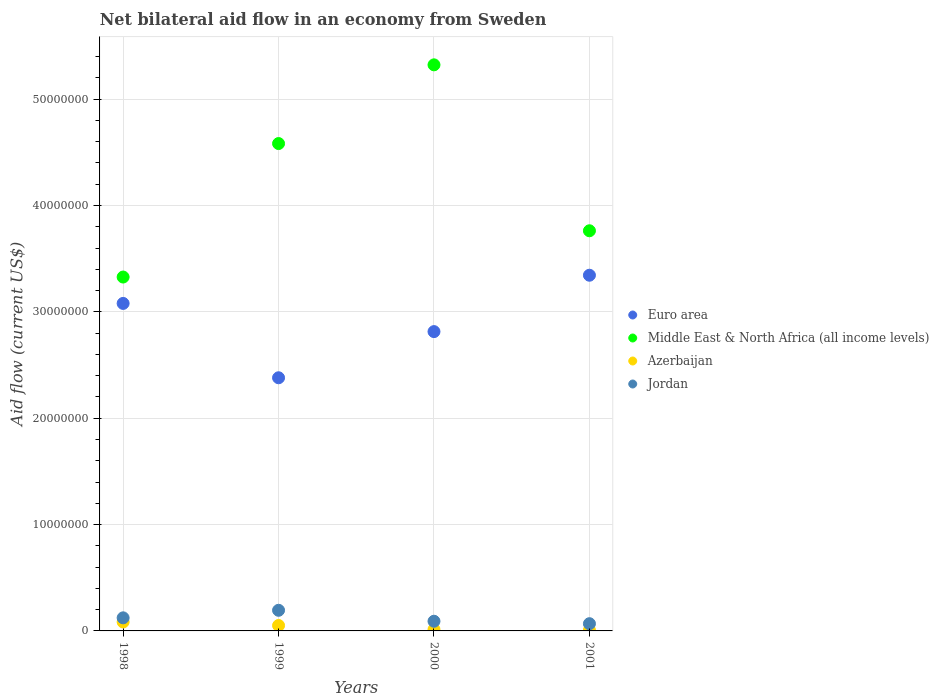How many different coloured dotlines are there?
Your answer should be very brief. 4. Is the number of dotlines equal to the number of legend labels?
Make the answer very short. Yes. What is the net bilateral aid flow in Middle East & North Africa (all income levels) in 1999?
Give a very brief answer. 4.58e+07. Across all years, what is the maximum net bilateral aid flow in Azerbaijan?
Your answer should be compact. 8.40e+05. Across all years, what is the minimum net bilateral aid flow in Middle East & North Africa (all income levels)?
Your answer should be compact. 3.33e+07. What is the total net bilateral aid flow in Jordan in the graph?
Your answer should be very brief. 4.76e+06. What is the difference between the net bilateral aid flow in Euro area in 1998 and that in 2001?
Offer a very short reply. -2.65e+06. What is the difference between the net bilateral aid flow in Jordan in 1999 and the net bilateral aid flow in Middle East & North Africa (all income levels) in 2001?
Make the answer very short. -3.57e+07. What is the average net bilateral aid flow in Middle East & North Africa (all income levels) per year?
Your response must be concise. 4.25e+07. What is the ratio of the net bilateral aid flow in Azerbaijan in 2000 to that in 2001?
Offer a very short reply. 1.86. Is the difference between the net bilateral aid flow in Jordan in 1998 and 2001 greater than the difference between the net bilateral aid flow in Azerbaijan in 1998 and 2001?
Provide a short and direct response. No. What is the difference between the highest and the second highest net bilateral aid flow in Middle East & North Africa (all income levels)?
Give a very brief answer. 7.40e+06. What is the difference between the highest and the lowest net bilateral aid flow in Middle East & North Africa (all income levels)?
Your answer should be very brief. 2.00e+07. Is the sum of the net bilateral aid flow in Middle East & North Africa (all income levels) in 2000 and 2001 greater than the maximum net bilateral aid flow in Euro area across all years?
Offer a terse response. Yes. Does the net bilateral aid flow in Middle East & North Africa (all income levels) monotonically increase over the years?
Provide a succinct answer. No. How many dotlines are there?
Offer a very short reply. 4. How many years are there in the graph?
Your answer should be very brief. 4. What is the difference between two consecutive major ticks on the Y-axis?
Your answer should be very brief. 1.00e+07. Does the graph contain grids?
Your response must be concise. Yes. Where does the legend appear in the graph?
Offer a very short reply. Center right. What is the title of the graph?
Your answer should be very brief. Net bilateral aid flow in an economy from Sweden. Does "Estonia" appear as one of the legend labels in the graph?
Offer a terse response. No. What is the label or title of the X-axis?
Your answer should be compact. Years. What is the label or title of the Y-axis?
Your response must be concise. Aid flow (current US$). What is the Aid flow (current US$) of Euro area in 1998?
Ensure brevity in your answer.  3.08e+07. What is the Aid flow (current US$) of Middle East & North Africa (all income levels) in 1998?
Your response must be concise. 3.33e+07. What is the Aid flow (current US$) of Azerbaijan in 1998?
Your answer should be very brief. 8.40e+05. What is the Aid flow (current US$) in Jordan in 1998?
Keep it short and to the point. 1.23e+06. What is the Aid flow (current US$) in Euro area in 1999?
Make the answer very short. 2.38e+07. What is the Aid flow (current US$) in Middle East & North Africa (all income levels) in 1999?
Give a very brief answer. 4.58e+07. What is the Aid flow (current US$) in Azerbaijan in 1999?
Ensure brevity in your answer.  5.10e+05. What is the Aid flow (current US$) in Jordan in 1999?
Your answer should be very brief. 1.94e+06. What is the Aid flow (current US$) of Euro area in 2000?
Offer a very short reply. 2.81e+07. What is the Aid flow (current US$) in Middle East & North Africa (all income levels) in 2000?
Offer a terse response. 5.32e+07. What is the Aid flow (current US$) of Azerbaijan in 2000?
Make the answer very short. 1.30e+05. What is the Aid flow (current US$) of Jordan in 2000?
Make the answer very short. 9.10e+05. What is the Aid flow (current US$) in Euro area in 2001?
Your response must be concise. 3.34e+07. What is the Aid flow (current US$) in Middle East & North Africa (all income levels) in 2001?
Make the answer very short. 3.76e+07. What is the Aid flow (current US$) in Azerbaijan in 2001?
Your answer should be very brief. 7.00e+04. What is the Aid flow (current US$) in Jordan in 2001?
Keep it short and to the point. 6.80e+05. Across all years, what is the maximum Aid flow (current US$) of Euro area?
Provide a succinct answer. 3.34e+07. Across all years, what is the maximum Aid flow (current US$) in Middle East & North Africa (all income levels)?
Make the answer very short. 5.32e+07. Across all years, what is the maximum Aid flow (current US$) of Azerbaijan?
Ensure brevity in your answer.  8.40e+05. Across all years, what is the maximum Aid flow (current US$) in Jordan?
Offer a very short reply. 1.94e+06. Across all years, what is the minimum Aid flow (current US$) in Euro area?
Your answer should be very brief. 2.38e+07. Across all years, what is the minimum Aid flow (current US$) in Middle East & North Africa (all income levels)?
Keep it short and to the point. 3.33e+07. Across all years, what is the minimum Aid flow (current US$) of Jordan?
Make the answer very short. 6.80e+05. What is the total Aid flow (current US$) of Euro area in the graph?
Make the answer very short. 1.16e+08. What is the total Aid flow (current US$) of Middle East & North Africa (all income levels) in the graph?
Your response must be concise. 1.70e+08. What is the total Aid flow (current US$) of Azerbaijan in the graph?
Provide a succinct answer. 1.55e+06. What is the total Aid flow (current US$) in Jordan in the graph?
Keep it short and to the point. 4.76e+06. What is the difference between the Aid flow (current US$) of Euro area in 1998 and that in 1999?
Provide a short and direct response. 6.99e+06. What is the difference between the Aid flow (current US$) of Middle East & North Africa (all income levels) in 1998 and that in 1999?
Provide a short and direct response. -1.26e+07. What is the difference between the Aid flow (current US$) of Jordan in 1998 and that in 1999?
Provide a short and direct response. -7.10e+05. What is the difference between the Aid flow (current US$) in Euro area in 1998 and that in 2000?
Make the answer very short. 2.65e+06. What is the difference between the Aid flow (current US$) of Middle East & North Africa (all income levels) in 1998 and that in 2000?
Give a very brief answer. -2.00e+07. What is the difference between the Aid flow (current US$) of Azerbaijan in 1998 and that in 2000?
Make the answer very short. 7.10e+05. What is the difference between the Aid flow (current US$) in Jordan in 1998 and that in 2000?
Make the answer very short. 3.20e+05. What is the difference between the Aid flow (current US$) in Euro area in 1998 and that in 2001?
Provide a short and direct response. -2.65e+06. What is the difference between the Aid flow (current US$) of Middle East & North Africa (all income levels) in 1998 and that in 2001?
Provide a short and direct response. -4.35e+06. What is the difference between the Aid flow (current US$) in Azerbaijan in 1998 and that in 2001?
Provide a succinct answer. 7.70e+05. What is the difference between the Aid flow (current US$) in Euro area in 1999 and that in 2000?
Keep it short and to the point. -4.34e+06. What is the difference between the Aid flow (current US$) of Middle East & North Africa (all income levels) in 1999 and that in 2000?
Give a very brief answer. -7.40e+06. What is the difference between the Aid flow (current US$) in Jordan in 1999 and that in 2000?
Make the answer very short. 1.03e+06. What is the difference between the Aid flow (current US$) in Euro area in 1999 and that in 2001?
Keep it short and to the point. -9.64e+06. What is the difference between the Aid flow (current US$) of Middle East & North Africa (all income levels) in 1999 and that in 2001?
Ensure brevity in your answer.  8.20e+06. What is the difference between the Aid flow (current US$) in Jordan in 1999 and that in 2001?
Your answer should be very brief. 1.26e+06. What is the difference between the Aid flow (current US$) of Euro area in 2000 and that in 2001?
Ensure brevity in your answer.  -5.30e+06. What is the difference between the Aid flow (current US$) of Middle East & North Africa (all income levels) in 2000 and that in 2001?
Offer a terse response. 1.56e+07. What is the difference between the Aid flow (current US$) in Jordan in 2000 and that in 2001?
Ensure brevity in your answer.  2.30e+05. What is the difference between the Aid flow (current US$) in Euro area in 1998 and the Aid flow (current US$) in Middle East & North Africa (all income levels) in 1999?
Provide a succinct answer. -1.50e+07. What is the difference between the Aid flow (current US$) in Euro area in 1998 and the Aid flow (current US$) in Azerbaijan in 1999?
Ensure brevity in your answer.  3.03e+07. What is the difference between the Aid flow (current US$) in Euro area in 1998 and the Aid flow (current US$) in Jordan in 1999?
Your response must be concise. 2.88e+07. What is the difference between the Aid flow (current US$) of Middle East & North Africa (all income levels) in 1998 and the Aid flow (current US$) of Azerbaijan in 1999?
Make the answer very short. 3.28e+07. What is the difference between the Aid flow (current US$) of Middle East & North Africa (all income levels) in 1998 and the Aid flow (current US$) of Jordan in 1999?
Make the answer very short. 3.13e+07. What is the difference between the Aid flow (current US$) in Azerbaijan in 1998 and the Aid flow (current US$) in Jordan in 1999?
Provide a short and direct response. -1.10e+06. What is the difference between the Aid flow (current US$) of Euro area in 1998 and the Aid flow (current US$) of Middle East & North Africa (all income levels) in 2000?
Give a very brief answer. -2.24e+07. What is the difference between the Aid flow (current US$) of Euro area in 1998 and the Aid flow (current US$) of Azerbaijan in 2000?
Give a very brief answer. 3.07e+07. What is the difference between the Aid flow (current US$) of Euro area in 1998 and the Aid flow (current US$) of Jordan in 2000?
Your response must be concise. 2.99e+07. What is the difference between the Aid flow (current US$) of Middle East & North Africa (all income levels) in 1998 and the Aid flow (current US$) of Azerbaijan in 2000?
Ensure brevity in your answer.  3.31e+07. What is the difference between the Aid flow (current US$) in Middle East & North Africa (all income levels) in 1998 and the Aid flow (current US$) in Jordan in 2000?
Ensure brevity in your answer.  3.24e+07. What is the difference between the Aid flow (current US$) in Euro area in 1998 and the Aid flow (current US$) in Middle East & North Africa (all income levels) in 2001?
Your answer should be compact. -6.83e+06. What is the difference between the Aid flow (current US$) of Euro area in 1998 and the Aid flow (current US$) of Azerbaijan in 2001?
Offer a very short reply. 3.07e+07. What is the difference between the Aid flow (current US$) of Euro area in 1998 and the Aid flow (current US$) of Jordan in 2001?
Your answer should be compact. 3.01e+07. What is the difference between the Aid flow (current US$) of Middle East & North Africa (all income levels) in 1998 and the Aid flow (current US$) of Azerbaijan in 2001?
Your answer should be very brief. 3.32e+07. What is the difference between the Aid flow (current US$) in Middle East & North Africa (all income levels) in 1998 and the Aid flow (current US$) in Jordan in 2001?
Provide a short and direct response. 3.26e+07. What is the difference between the Aid flow (current US$) in Azerbaijan in 1998 and the Aid flow (current US$) in Jordan in 2001?
Your response must be concise. 1.60e+05. What is the difference between the Aid flow (current US$) in Euro area in 1999 and the Aid flow (current US$) in Middle East & North Africa (all income levels) in 2000?
Give a very brief answer. -2.94e+07. What is the difference between the Aid flow (current US$) of Euro area in 1999 and the Aid flow (current US$) of Azerbaijan in 2000?
Provide a succinct answer. 2.37e+07. What is the difference between the Aid flow (current US$) in Euro area in 1999 and the Aid flow (current US$) in Jordan in 2000?
Offer a very short reply. 2.29e+07. What is the difference between the Aid flow (current US$) of Middle East & North Africa (all income levels) in 1999 and the Aid flow (current US$) of Azerbaijan in 2000?
Make the answer very short. 4.57e+07. What is the difference between the Aid flow (current US$) in Middle East & North Africa (all income levels) in 1999 and the Aid flow (current US$) in Jordan in 2000?
Offer a terse response. 4.49e+07. What is the difference between the Aid flow (current US$) of Azerbaijan in 1999 and the Aid flow (current US$) of Jordan in 2000?
Your answer should be compact. -4.00e+05. What is the difference between the Aid flow (current US$) in Euro area in 1999 and the Aid flow (current US$) in Middle East & North Africa (all income levels) in 2001?
Offer a terse response. -1.38e+07. What is the difference between the Aid flow (current US$) of Euro area in 1999 and the Aid flow (current US$) of Azerbaijan in 2001?
Your response must be concise. 2.37e+07. What is the difference between the Aid flow (current US$) of Euro area in 1999 and the Aid flow (current US$) of Jordan in 2001?
Your answer should be very brief. 2.31e+07. What is the difference between the Aid flow (current US$) in Middle East & North Africa (all income levels) in 1999 and the Aid flow (current US$) in Azerbaijan in 2001?
Make the answer very short. 4.58e+07. What is the difference between the Aid flow (current US$) of Middle East & North Africa (all income levels) in 1999 and the Aid flow (current US$) of Jordan in 2001?
Provide a succinct answer. 4.51e+07. What is the difference between the Aid flow (current US$) in Azerbaijan in 1999 and the Aid flow (current US$) in Jordan in 2001?
Your answer should be compact. -1.70e+05. What is the difference between the Aid flow (current US$) in Euro area in 2000 and the Aid flow (current US$) in Middle East & North Africa (all income levels) in 2001?
Provide a succinct answer. -9.48e+06. What is the difference between the Aid flow (current US$) of Euro area in 2000 and the Aid flow (current US$) of Azerbaijan in 2001?
Provide a succinct answer. 2.81e+07. What is the difference between the Aid flow (current US$) of Euro area in 2000 and the Aid flow (current US$) of Jordan in 2001?
Make the answer very short. 2.75e+07. What is the difference between the Aid flow (current US$) of Middle East & North Africa (all income levels) in 2000 and the Aid flow (current US$) of Azerbaijan in 2001?
Ensure brevity in your answer.  5.32e+07. What is the difference between the Aid flow (current US$) in Middle East & North Africa (all income levels) in 2000 and the Aid flow (current US$) in Jordan in 2001?
Offer a terse response. 5.25e+07. What is the difference between the Aid flow (current US$) in Azerbaijan in 2000 and the Aid flow (current US$) in Jordan in 2001?
Offer a very short reply. -5.50e+05. What is the average Aid flow (current US$) in Euro area per year?
Ensure brevity in your answer.  2.90e+07. What is the average Aid flow (current US$) in Middle East & North Africa (all income levels) per year?
Provide a short and direct response. 4.25e+07. What is the average Aid flow (current US$) of Azerbaijan per year?
Provide a short and direct response. 3.88e+05. What is the average Aid flow (current US$) in Jordan per year?
Offer a very short reply. 1.19e+06. In the year 1998, what is the difference between the Aid flow (current US$) of Euro area and Aid flow (current US$) of Middle East & North Africa (all income levels)?
Offer a very short reply. -2.48e+06. In the year 1998, what is the difference between the Aid flow (current US$) of Euro area and Aid flow (current US$) of Azerbaijan?
Provide a short and direct response. 3.00e+07. In the year 1998, what is the difference between the Aid flow (current US$) in Euro area and Aid flow (current US$) in Jordan?
Provide a short and direct response. 2.96e+07. In the year 1998, what is the difference between the Aid flow (current US$) of Middle East & North Africa (all income levels) and Aid flow (current US$) of Azerbaijan?
Ensure brevity in your answer.  3.24e+07. In the year 1998, what is the difference between the Aid flow (current US$) in Middle East & North Africa (all income levels) and Aid flow (current US$) in Jordan?
Provide a short and direct response. 3.20e+07. In the year 1998, what is the difference between the Aid flow (current US$) in Azerbaijan and Aid flow (current US$) in Jordan?
Your response must be concise. -3.90e+05. In the year 1999, what is the difference between the Aid flow (current US$) of Euro area and Aid flow (current US$) of Middle East & North Africa (all income levels)?
Ensure brevity in your answer.  -2.20e+07. In the year 1999, what is the difference between the Aid flow (current US$) of Euro area and Aid flow (current US$) of Azerbaijan?
Keep it short and to the point. 2.33e+07. In the year 1999, what is the difference between the Aid flow (current US$) in Euro area and Aid flow (current US$) in Jordan?
Ensure brevity in your answer.  2.19e+07. In the year 1999, what is the difference between the Aid flow (current US$) in Middle East & North Africa (all income levels) and Aid flow (current US$) in Azerbaijan?
Offer a terse response. 4.53e+07. In the year 1999, what is the difference between the Aid flow (current US$) in Middle East & North Africa (all income levels) and Aid flow (current US$) in Jordan?
Offer a very short reply. 4.39e+07. In the year 1999, what is the difference between the Aid flow (current US$) in Azerbaijan and Aid flow (current US$) in Jordan?
Ensure brevity in your answer.  -1.43e+06. In the year 2000, what is the difference between the Aid flow (current US$) in Euro area and Aid flow (current US$) in Middle East & North Africa (all income levels)?
Give a very brief answer. -2.51e+07. In the year 2000, what is the difference between the Aid flow (current US$) of Euro area and Aid flow (current US$) of Azerbaijan?
Your answer should be compact. 2.80e+07. In the year 2000, what is the difference between the Aid flow (current US$) of Euro area and Aid flow (current US$) of Jordan?
Offer a very short reply. 2.72e+07. In the year 2000, what is the difference between the Aid flow (current US$) in Middle East & North Africa (all income levels) and Aid flow (current US$) in Azerbaijan?
Ensure brevity in your answer.  5.31e+07. In the year 2000, what is the difference between the Aid flow (current US$) of Middle East & North Africa (all income levels) and Aid flow (current US$) of Jordan?
Your answer should be very brief. 5.23e+07. In the year 2000, what is the difference between the Aid flow (current US$) of Azerbaijan and Aid flow (current US$) of Jordan?
Ensure brevity in your answer.  -7.80e+05. In the year 2001, what is the difference between the Aid flow (current US$) in Euro area and Aid flow (current US$) in Middle East & North Africa (all income levels)?
Ensure brevity in your answer.  -4.18e+06. In the year 2001, what is the difference between the Aid flow (current US$) in Euro area and Aid flow (current US$) in Azerbaijan?
Your response must be concise. 3.34e+07. In the year 2001, what is the difference between the Aid flow (current US$) in Euro area and Aid flow (current US$) in Jordan?
Your answer should be very brief. 3.28e+07. In the year 2001, what is the difference between the Aid flow (current US$) in Middle East & North Africa (all income levels) and Aid flow (current US$) in Azerbaijan?
Your response must be concise. 3.76e+07. In the year 2001, what is the difference between the Aid flow (current US$) of Middle East & North Africa (all income levels) and Aid flow (current US$) of Jordan?
Give a very brief answer. 3.69e+07. In the year 2001, what is the difference between the Aid flow (current US$) of Azerbaijan and Aid flow (current US$) of Jordan?
Give a very brief answer. -6.10e+05. What is the ratio of the Aid flow (current US$) in Euro area in 1998 to that in 1999?
Make the answer very short. 1.29. What is the ratio of the Aid flow (current US$) in Middle East & North Africa (all income levels) in 1998 to that in 1999?
Offer a terse response. 0.73. What is the ratio of the Aid flow (current US$) in Azerbaijan in 1998 to that in 1999?
Offer a terse response. 1.65. What is the ratio of the Aid flow (current US$) in Jordan in 1998 to that in 1999?
Your answer should be very brief. 0.63. What is the ratio of the Aid flow (current US$) of Euro area in 1998 to that in 2000?
Give a very brief answer. 1.09. What is the ratio of the Aid flow (current US$) of Middle East & North Africa (all income levels) in 1998 to that in 2000?
Provide a short and direct response. 0.63. What is the ratio of the Aid flow (current US$) in Azerbaijan in 1998 to that in 2000?
Your response must be concise. 6.46. What is the ratio of the Aid flow (current US$) of Jordan in 1998 to that in 2000?
Your response must be concise. 1.35. What is the ratio of the Aid flow (current US$) of Euro area in 1998 to that in 2001?
Your answer should be compact. 0.92. What is the ratio of the Aid flow (current US$) in Middle East & North Africa (all income levels) in 1998 to that in 2001?
Offer a very short reply. 0.88. What is the ratio of the Aid flow (current US$) of Azerbaijan in 1998 to that in 2001?
Offer a terse response. 12. What is the ratio of the Aid flow (current US$) in Jordan in 1998 to that in 2001?
Offer a terse response. 1.81. What is the ratio of the Aid flow (current US$) of Euro area in 1999 to that in 2000?
Your answer should be very brief. 0.85. What is the ratio of the Aid flow (current US$) in Middle East & North Africa (all income levels) in 1999 to that in 2000?
Your answer should be compact. 0.86. What is the ratio of the Aid flow (current US$) in Azerbaijan in 1999 to that in 2000?
Offer a terse response. 3.92. What is the ratio of the Aid flow (current US$) in Jordan in 1999 to that in 2000?
Give a very brief answer. 2.13. What is the ratio of the Aid flow (current US$) of Euro area in 1999 to that in 2001?
Provide a short and direct response. 0.71. What is the ratio of the Aid flow (current US$) of Middle East & North Africa (all income levels) in 1999 to that in 2001?
Your answer should be very brief. 1.22. What is the ratio of the Aid flow (current US$) in Azerbaijan in 1999 to that in 2001?
Offer a very short reply. 7.29. What is the ratio of the Aid flow (current US$) of Jordan in 1999 to that in 2001?
Provide a short and direct response. 2.85. What is the ratio of the Aid flow (current US$) in Euro area in 2000 to that in 2001?
Your answer should be very brief. 0.84. What is the ratio of the Aid flow (current US$) of Middle East & North Africa (all income levels) in 2000 to that in 2001?
Offer a terse response. 1.41. What is the ratio of the Aid flow (current US$) in Azerbaijan in 2000 to that in 2001?
Your answer should be compact. 1.86. What is the ratio of the Aid flow (current US$) in Jordan in 2000 to that in 2001?
Your answer should be very brief. 1.34. What is the difference between the highest and the second highest Aid flow (current US$) in Euro area?
Your answer should be compact. 2.65e+06. What is the difference between the highest and the second highest Aid flow (current US$) of Middle East & North Africa (all income levels)?
Make the answer very short. 7.40e+06. What is the difference between the highest and the second highest Aid flow (current US$) of Azerbaijan?
Make the answer very short. 3.30e+05. What is the difference between the highest and the second highest Aid flow (current US$) of Jordan?
Make the answer very short. 7.10e+05. What is the difference between the highest and the lowest Aid flow (current US$) in Euro area?
Provide a succinct answer. 9.64e+06. What is the difference between the highest and the lowest Aid flow (current US$) of Middle East & North Africa (all income levels)?
Your answer should be very brief. 2.00e+07. What is the difference between the highest and the lowest Aid flow (current US$) in Azerbaijan?
Keep it short and to the point. 7.70e+05. What is the difference between the highest and the lowest Aid flow (current US$) of Jordan?
Give a very brief answer. 1.26e+06. 